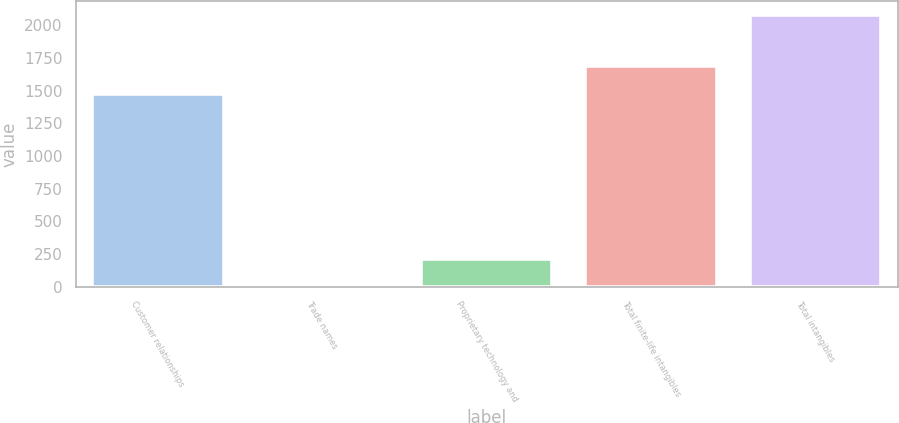Convert chart to OTSL. <chart><loc_0><loc_0><loc_500><loc_500><bar_chart><fcel>Customer relationships<fcel>Trade names<fcel>Proprietary technology and<fcel>Total finite-life intangibles<fcel>Total intangibles<nl><fcel>1478<fcel>1.8<fcel>209.64<fcel>1685.84<fcel>2080.2<nl></chart> 